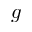Convert formula to latex. <formula><loc_0><loc_0><loc_500><loc_500>g</formula> 